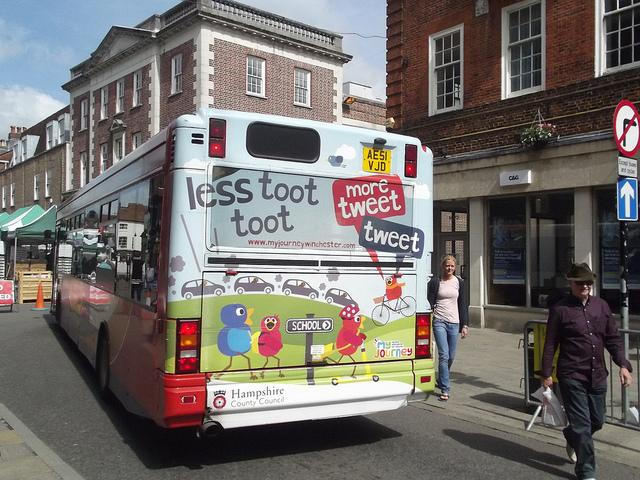Which direction will the bus go next? right 